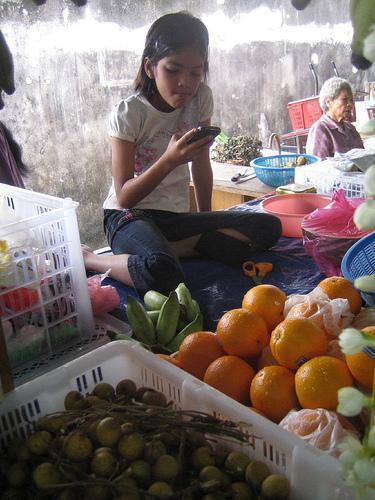How many people are there?
Give a very brief answer. 2. How many oranges are in the photo?
Give a very brief answer. 3. 